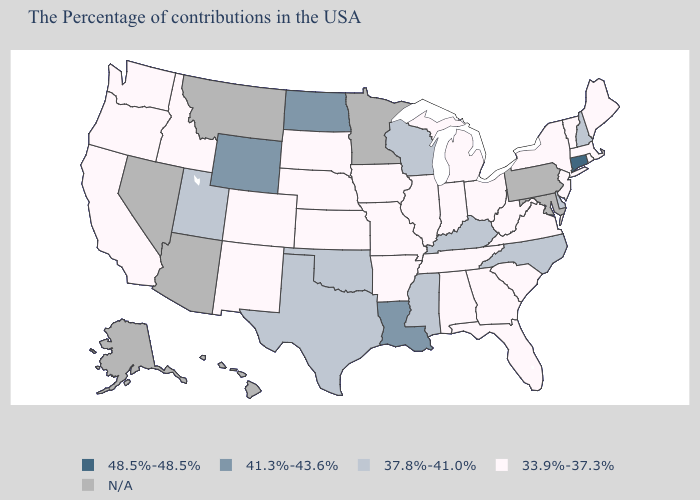Name the states that have a value in the range 37.8%-41.0%?
Short answer required. New Hampshire, Delaware, North Carolina, Kentucky, Wisconsin, Mississippi, Oklahoma, Texas, Utah. What is the highest value in states that border Tennessee?
Quick response, please. 37.8%-41.0%. Name the states that have a value in the range 33.9%-37.3%?
Quick response, please. Maine, Massachusetts, Rhode Island, Vermont, New York, New Jersey, Virginia, South Carolina, West Virginia, Ohio, Florida, Georgia, Michigan, Indiana, Alabama, Tennessee, Illinois, Missouri, Arkansas, Iowa, Kansas, Nebraska, South Dakota, Colorado, New Mexico, Idaho, California, Washington, Oregon. What is the lowest value in the USA?
Give a very brief answer. 33.9%-37.3%. Does the first symbol in the legend represent the smallest category?
Short answer required. No. What is the value of Florida?
Give a very brief answer. 33.9%-37.3%. Is the legend a continuous bar?
Be succinct. No. Does Connecticut have the highest value in the USA?
Be succinct. Yes. Which states have the lowest value in the USA?
Give a very brief answer. Maine, Massachusetts, Rhode Island, Vermont, New York, New Jersey, Virginia, South Carolina, West Virginia, Ohio, Florida, Georgia, Michigan, Indiana, Alabama, Tennessee, Illinois, Missouri, Arkansas, Iowa, Kansas, Nebraska, South Dakota, Colorado, New Mexico, Idaho, California, Washington, Oregon. Does North Carolina have the lowest value in the USA?
Quick response, please. No. Name the states that have a value in the range 33.9%-37.3%?
Write a very short answer. Maine, Massachusetts, Rhode Island, Vermont, New York, New Jersey, Virginia, South Carolina, West Virginia, Ohio, Florida, Georgia, Michigan, Indiana, Alabama, Tennessee, Illinois, Missouri, Arkansas, Iowa, Kansas, Nebraska, South Dakota, Colorado, New Mexico, Idaho, California, Washington, Oregon. What is the value of New Jersey?
Short answer required. 33.9%-37.3%. What is the highest value in the USA?
Short answer required. 48.5%-48.5%. Name the states that have a value in the range N/A?
Quick response, please. Maryland, Pennsylvania, Minnesota, Montana, Arizona, Nevada, Alaska, Hawaii. 